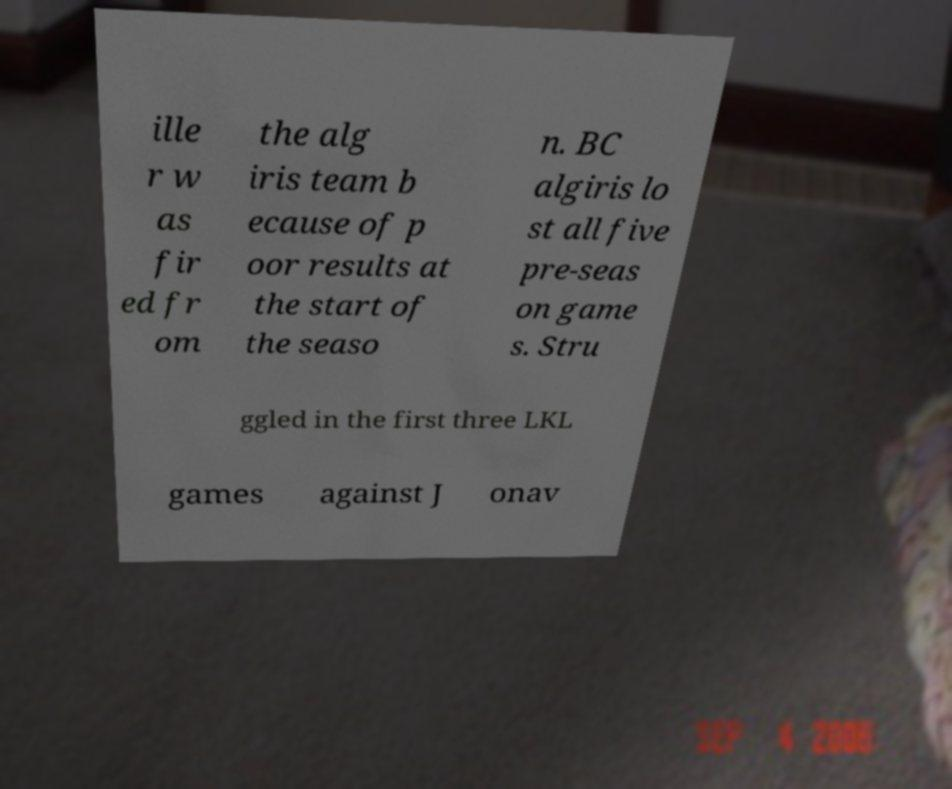I need the written content from this picture converted into text. Can you do that? ille r w as fir ed fr om the alg iris team b ecause of p oor results at the start of the seaso n. BC algiris lo st all five pre-seas on game s. Stru ggled in the first three LKL games against J onav 